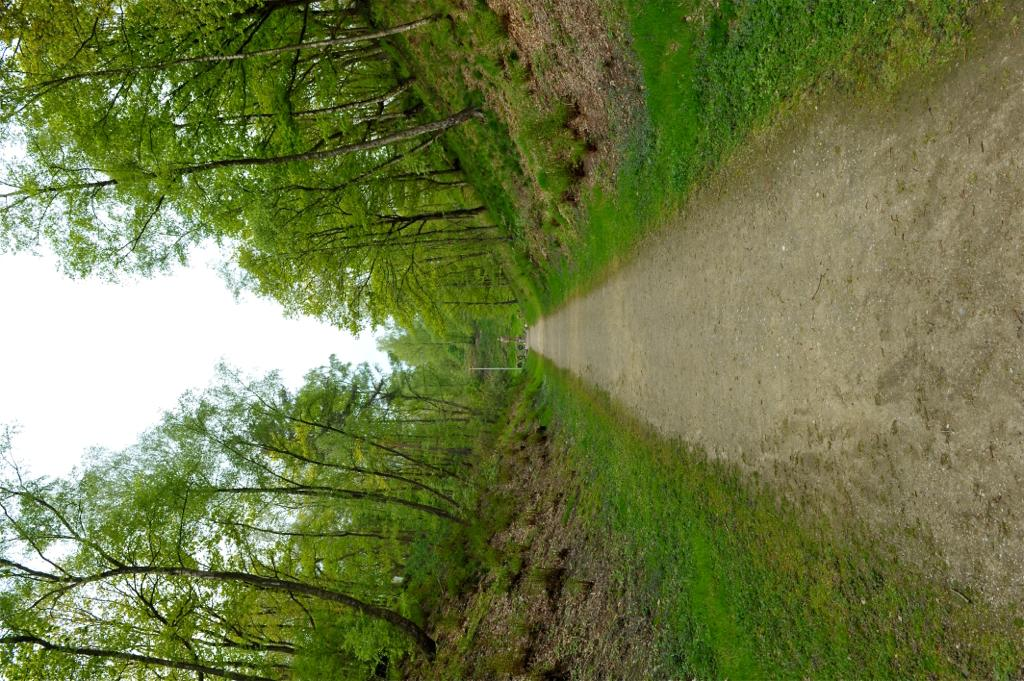What type of vegetation is present in the image? There is grass and trees in the image. Can you describe the natural environment depicted in the image? The image features a natural environment with grass and trees. How many pests can be seen crawling on the plants in the image? There are no pests visible in the image; it only features grass and trees. What type of rabbit can be seen hopping through the grass in the image? There is no rabbit present in the image; it only features grass and trees. 